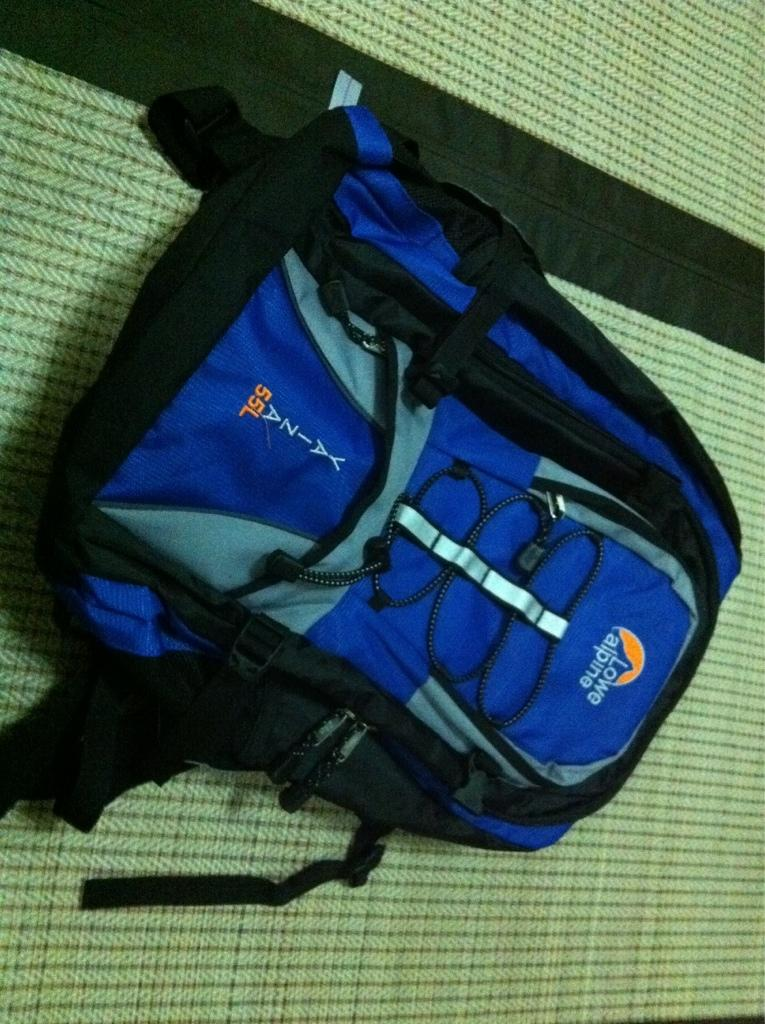What color is the bag in the image? The bag in the image is blue. What is the bag placed on in the image? The bag is on an object. What song is the stranger singing in the image? There is no stranger or song present in the image; it only features a blue color bag on an object. 